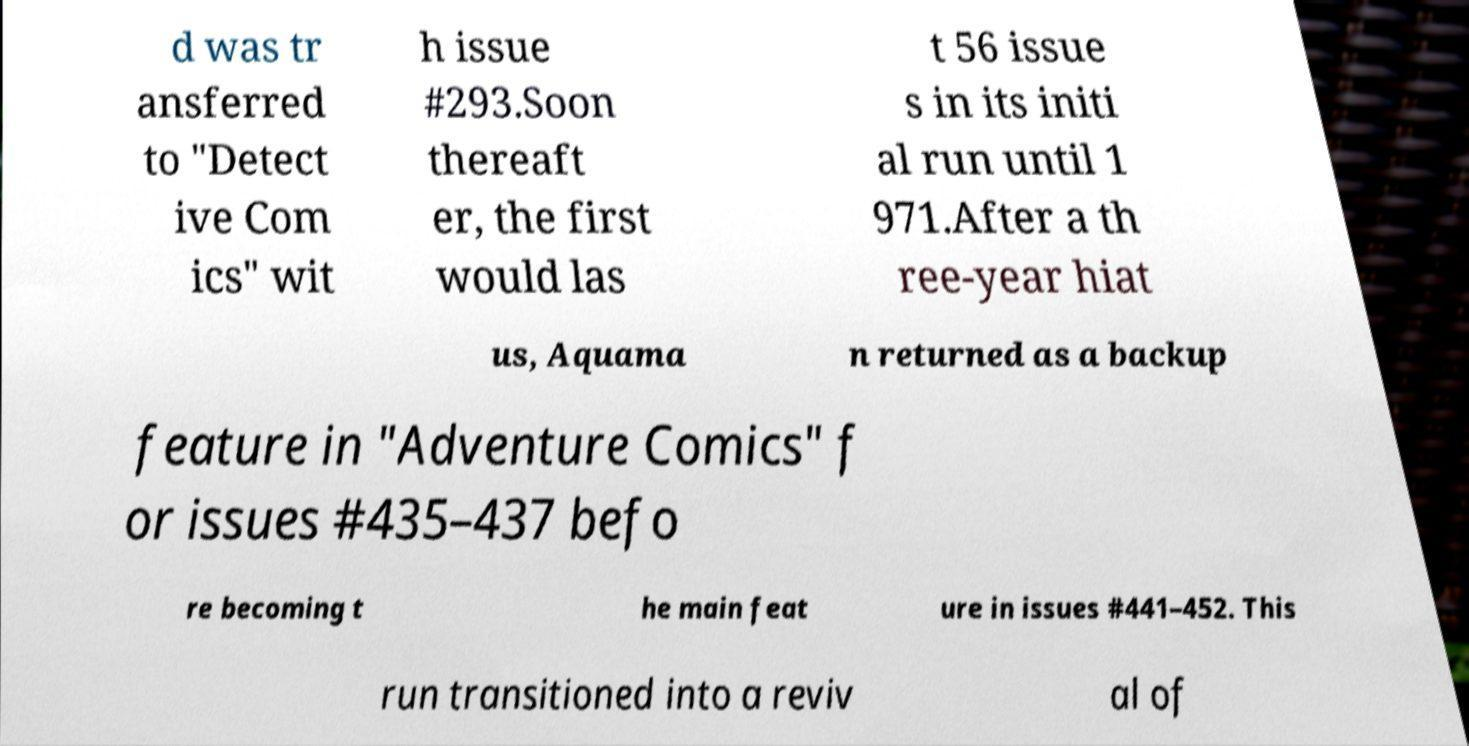Can you accurately transcribe the text from the provided image for me? d was tr ansferred to "Detect ive Com ics" wit h issue #293.Soon thereaft er, the first would las t 56 issue s in its initi al run until 1 971.After a th ree-year hiat us, Aquama n returned as a backup feature in "Adventure Comics" f or issues #435–437 befo re becoming t he main feat ure in issues #441–452. This run transitioned into a reviv al of 